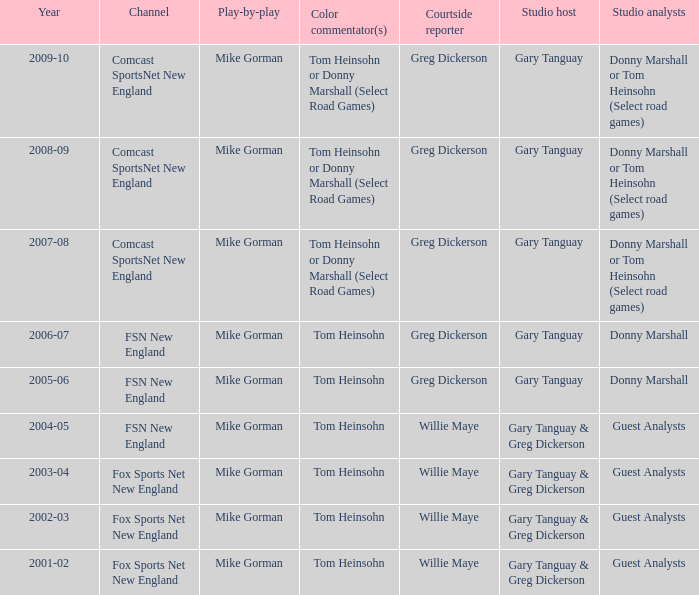Who served as the studio host during the 2006-07 year? Gary Tanguay. 